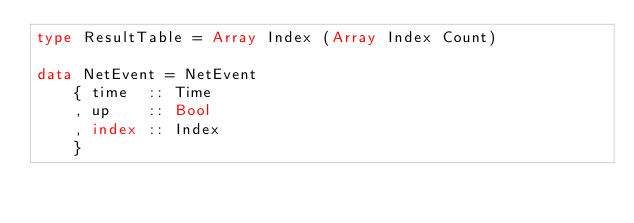Convert code to text. <code><loc_0><loc_0><loc_500><loc_500><_Haskell_>type ResultTable = Array Index (Array Index Count)

data NetEvent = NetEvent
    { time  :: Time
    , up    :: Bool
    , index :: Index
    }
</code> 